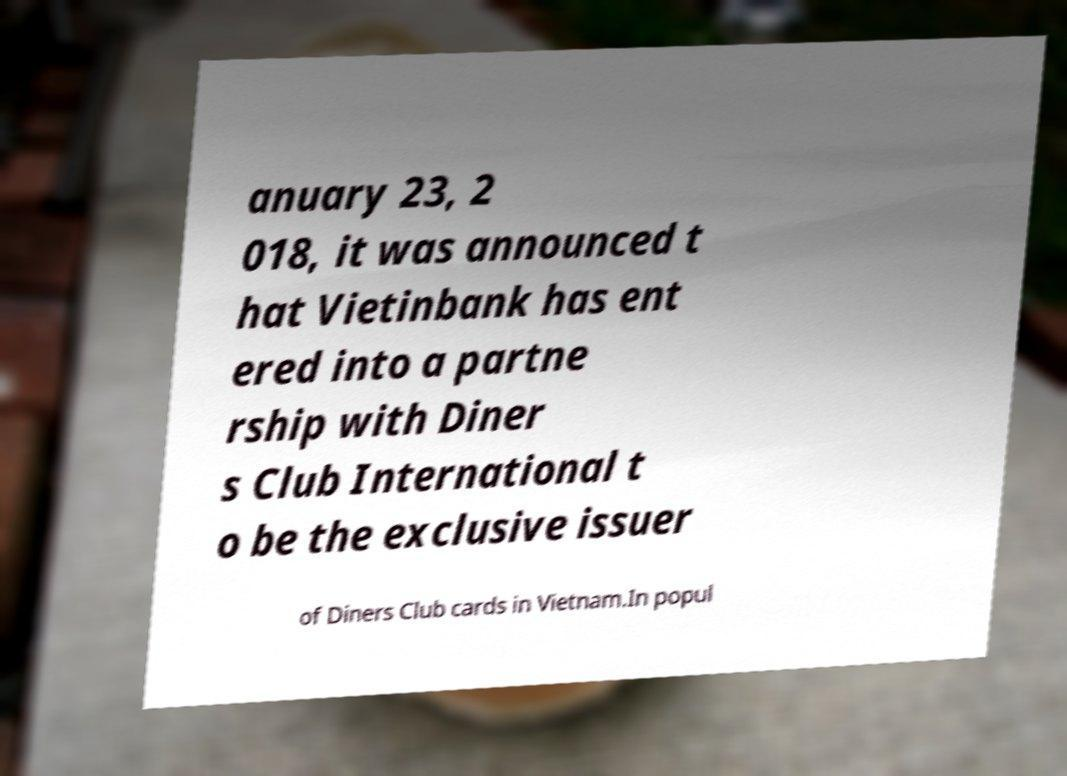What messages or text are displayed in this image? I need them in a readable, typed format. anuary 23, 2 018, it was announced t hat Vietinbank has ent ered into a partne rship with Diner s Club International t o be the exclusive issuer of Diners Club cards in Vietnam.In popul 